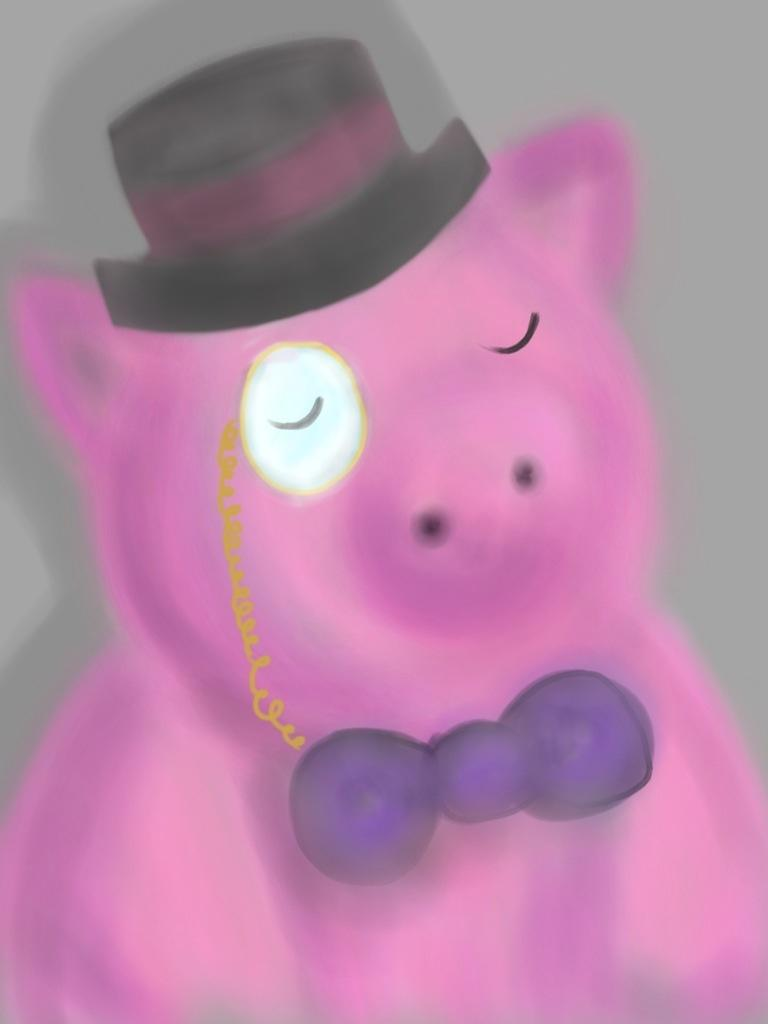What animal is depicted in the image? There is a pig in the image. What type of artwork is the image? The image appears to be a painting. What color is the pig in the image? The pig is pink in color. Where is the hat located in the image? There is a hat at the top of the image. What size is the wall that the pig is leaning against in the image? There is no wall present in the image; it only shows a pig and a hat. 